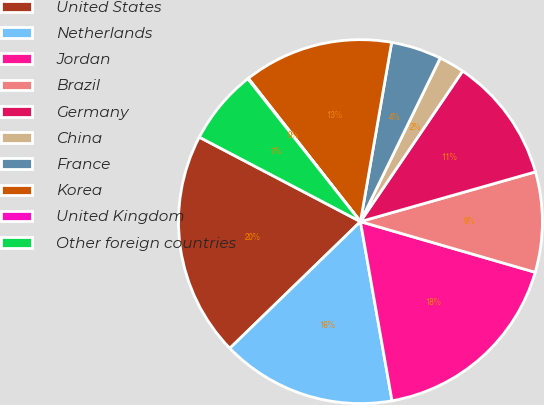Convert chart to OTSL. <chart><loc_0><loc_0><loc_500><loc_500><pie_chart><fcel>United States<fcel>Netherlands<fcel>Jordan<fcel>Brazil<fcel>Germany<fcel>China<fcel>France<fcel>Korea<fcel>United Kingdom<fcel>Other foreign countries<nl><fcel>19.94%<fcel>15.52%<fcel>17.73%<fcel>8.9%<fcel>11.1%<fcel>2.27%<fcel>4.48%<fcel>13.31%<fcel>0.06%<fcel>6.69%<nl></chart> 